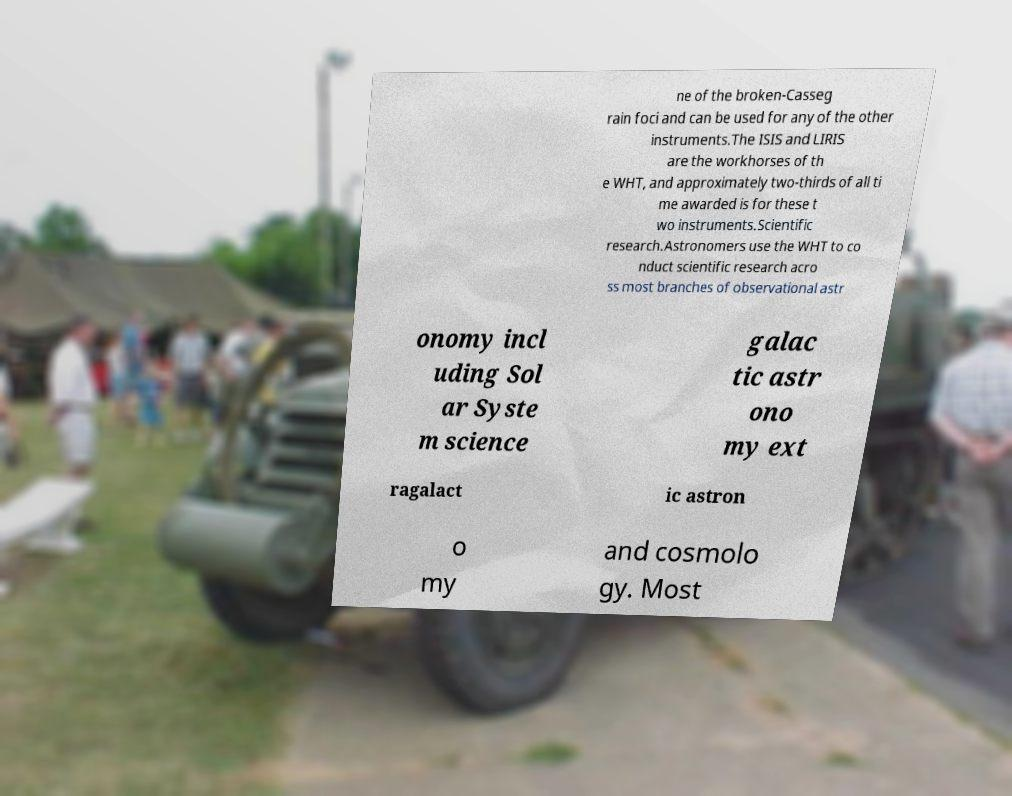Please identify and transcribe the text found in this image. ne of the broken-Casseg rain foci and can be used for any of the other instruments.The ISIS and LIRIS are the workhorses of th e WHT, and approximately two-thirds of all ti me awarded is for these t wo instruments.Scientific research.Astronomers use the WHT to co nduct scientific research acro ss most branches of observational astr onomy incl uding Sol ar Syste m science galac tic astr ono my ext ragalact ic astron o my and cosmolo gy. Most 